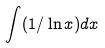<formula> <loc_0><loc_0><loc_500><loc_500>\int ( 1 / \ln x ) d x</formula> 